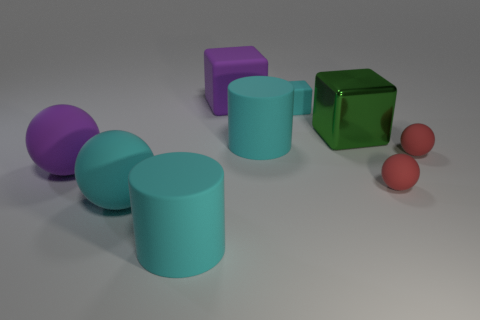Can you tell me which objects are the smallest in the image? The smallest objects in the image are the two small spheres located near the front. 